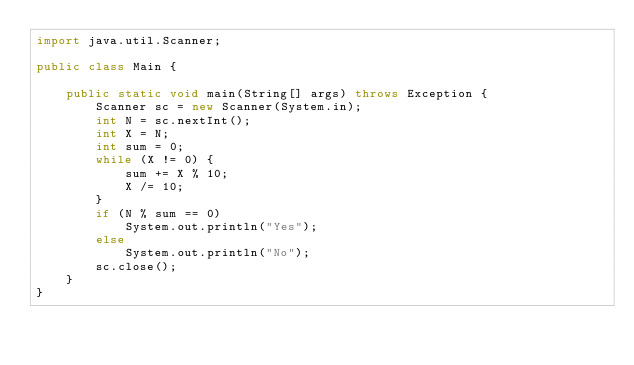<code> <loc_0><loc_0><loc_500><loc_500><_Java_>import java.util.Scanner;

public class Main {

	public static void main(String[] args) throws Exception {
		Scanner sc = new Scanner(System.in);
		int N = sc.nextInt();
		int X = N;
		int sum = 0;
		while (X != 0) {
			sum += X % 10;
			X /= 10;
		}
		if (N % sum == 0)
			System.out.println("Yes");
		else
			System.out.println("No");
		sc.close();
	}
}</code> 